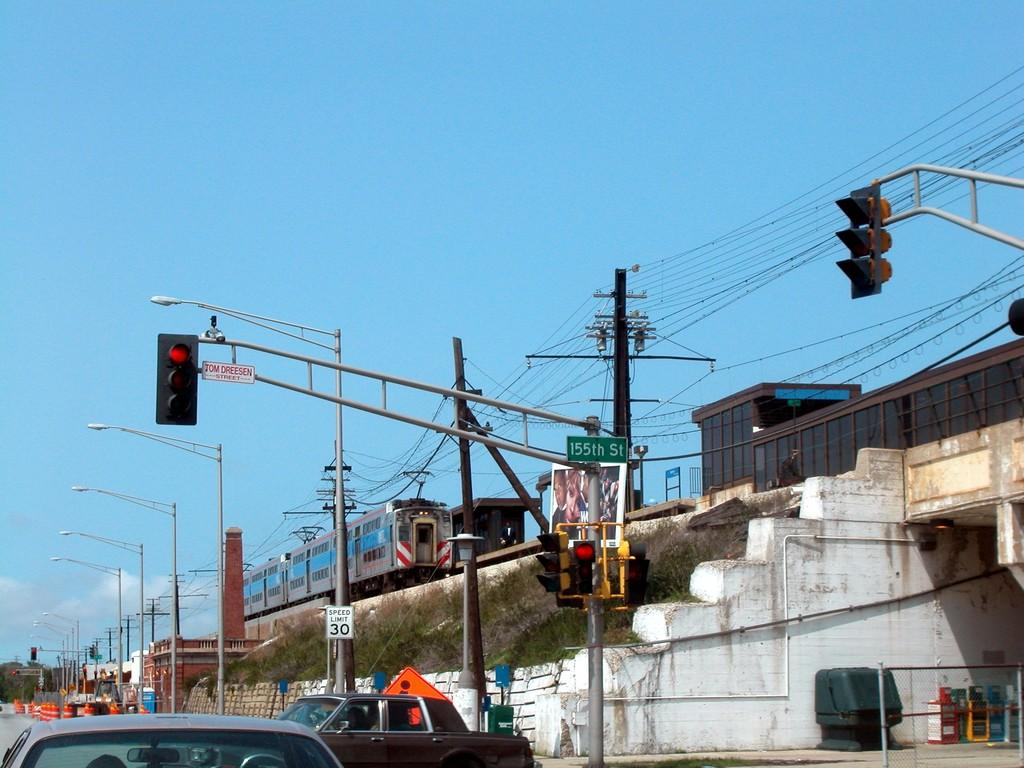<image>
Give a short and clear explanation of the subsequent image. The streetlights at 155th street are turned red. 